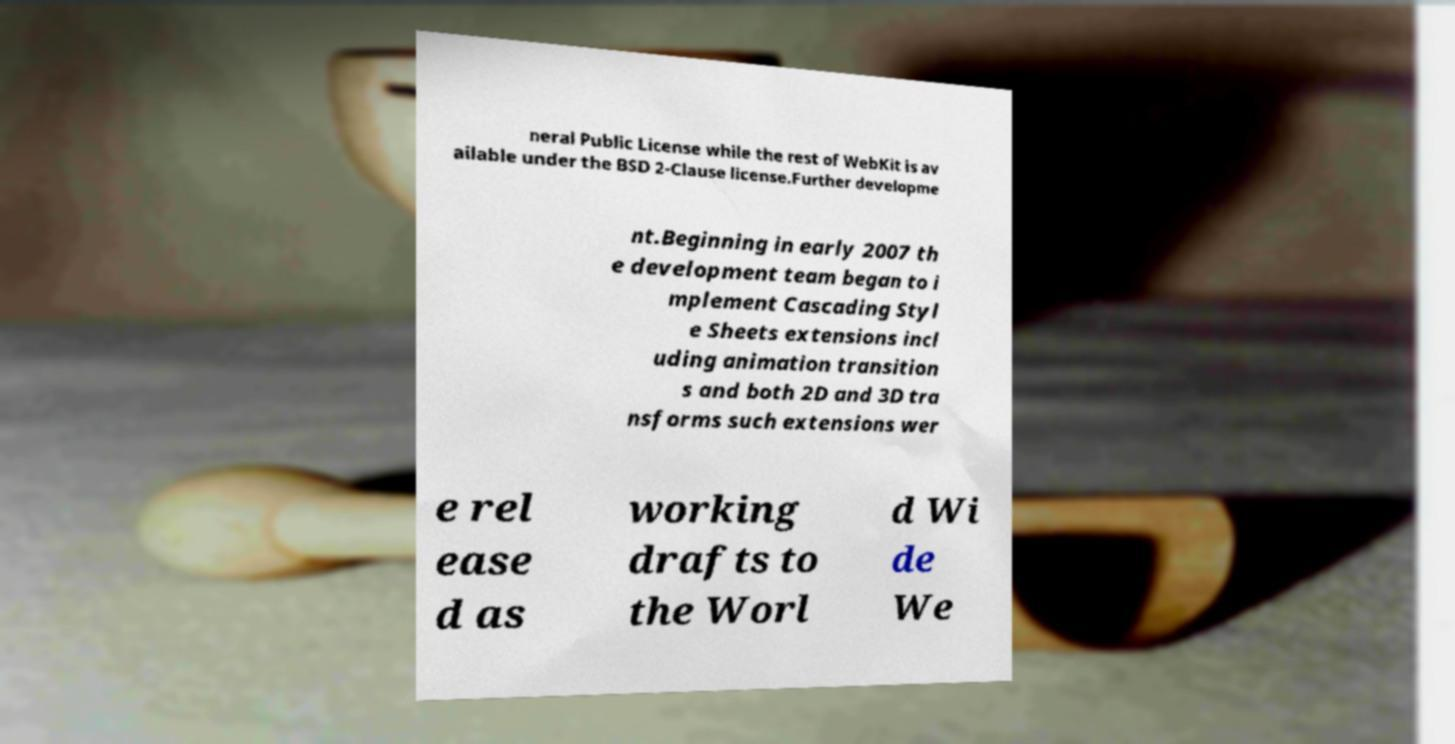For documentation purposes, I need the text within this image transcribed. Could you provide that? neral Public License while the rest of WebKit is av ailable under the BSD 2-Clause license.Further developme nt.Beginning in early 2007 th e development team began to i mplement Cascading Styl e Sheets extensions incl uding animation transition s and both 2D and 3D tra nsforms such extensions wer e rel ease d as working drafts to the Worl d Wi de We 